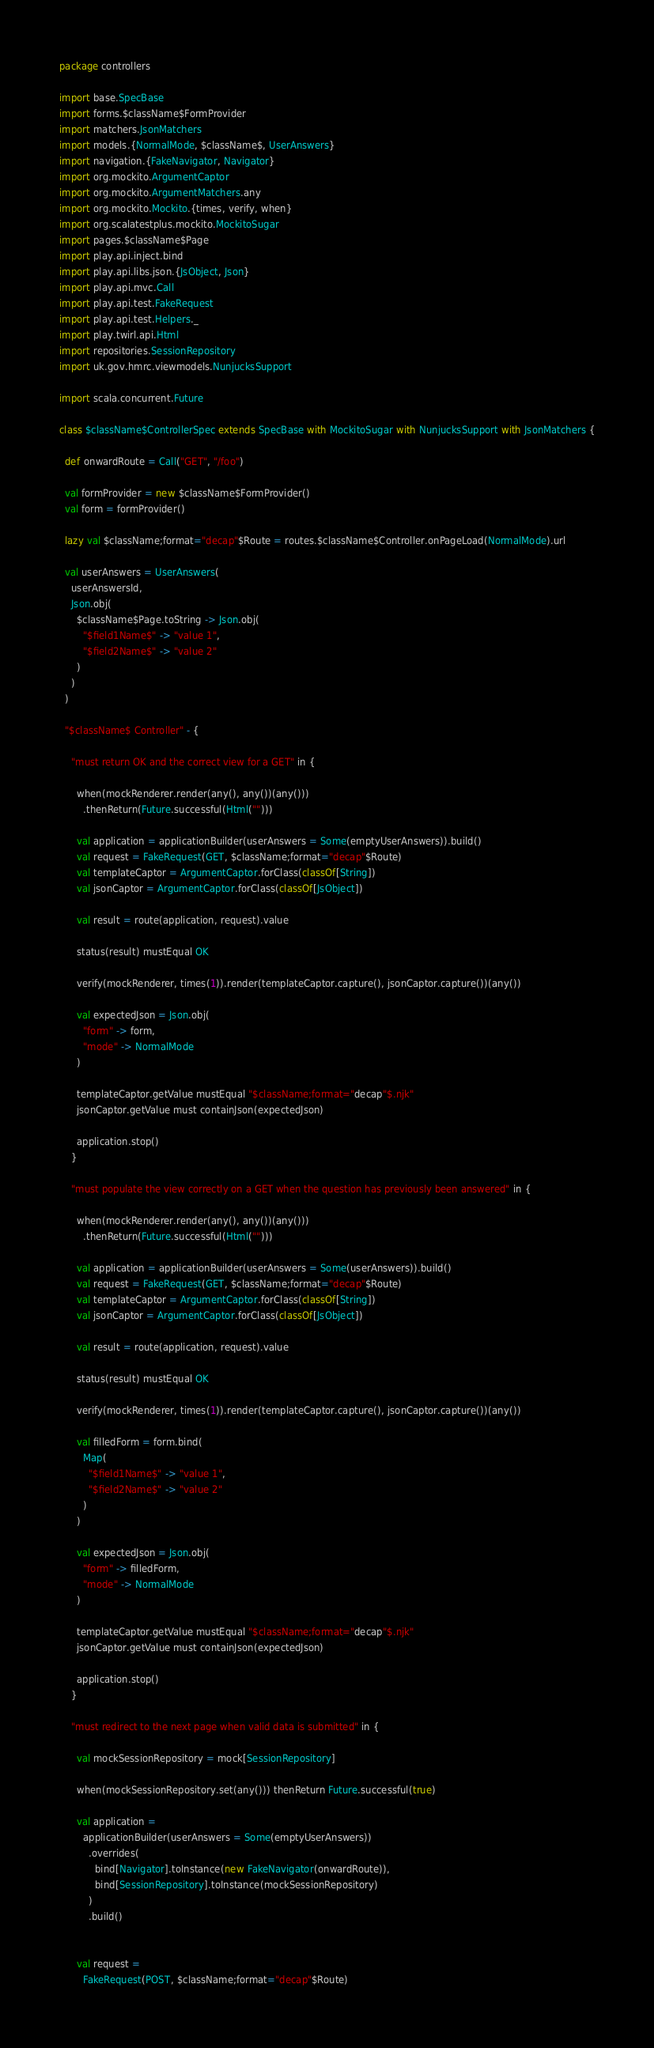<code> <loc_0><loc_0><loc_500><loc_500><_Scala_>package controllers

import base.SpecBase
import forms.$className$FormProvider
import matchers.JsonMatchers
import models.{NormalMode, $className$, UserAnswers}
import navigation.{FakeNavigator, Navigator}
import org.mockito.ArgumentCaptor
import org.mockito.ArgumentMatchers.any
import org.mockito.Mockito.{times, verify, when}
import org.scalatestplus.mockito.MockitoSugar
import pages.$className$Page
import play.api.inject.bind
import play.api.libs.json.{JsObject, Json}
import play.api.mvc.Call
import play.api.test.FakeRequest
import play.api.test.Helpers._
import play.twirl.api.Html
import repositories.SessionRepository
import uk.gov.hmrc.viewmodels.NunjucksSupport

import scala.concurrent.Future

class $className$ControllerSpec extends SpecBase with MockitoSugar with NunjucksSupport with JsonMatchers {

  def onwardRoute = Call("GET", "/foo")

  val formProvider = new $className$FormProvider()
  val form = formProvider()

  lazy val $className;format="decap"$Route = routes.$className$Controller.onPageLoad(NormalMode).url

  val userAnswers = UserAnswers(
    userAnswersId,
    Json.obj(
      $className$Page.toString -> Json.obj(
        "$field1Name$" -> "value 1",
        "$field2Name$" -> "value 2"
      )
    )
  )

  "$className$ Controller" - {

    "must return OK and the correct view for a GET" in {

      when(mockRenderer.render(any(), any())(any()))
        .thenReturn(Future.successful(Html("")))

      val application = applicationBuilder(userAnswers = Some(emptyUserAnswers)).build()
      val request = FakeRequest(GET, $className;format="decap"$Route)
      val templateCaptor = ArgumentCaptor.forClass(classOf[String])
      val jsonCaptor = ArgumentCaptor.forClass(classOf[JsObject])

      val result = route(application, request).value

      status(result) mustEqual OK

      verify(mockRenderer, times(1)).render(templateCaptor.capture(), jsonCaptor.capture())(any())

      val expectedJson = Json.obj(
        "form" -> form,
        "mode" -> NormalMode
      )

      templateCaptor.getValue mustEqual "$className;format="decap"$.njk"
      jsonCaptor.getValue must containJson(expectedJson)

      application.stop()
    }

    "must populate the view correctly on a GET when the question has previously been answered" in {

      when(mockRenderer.render(any(), any())(any()))
        .thenReturn(Future.successful(Html("")))

      val application = applicationBuilder(userAnswers = Some(userAnswers)).build()
      val request = FakeRequest(GET, $className;format="decap"$Route)
      val templateCaptor = ArgumentCaptor.forClass(classOf[String])
      val jsonCaptor = ArgumentCaptor.forClass(classOf[JsObject])

      val result = route(application, request).value

      status(result) mustEqual OK

      verify(mockRenderer, times(1)).render(templateCaptor.capture(), jsonCaptor.capture())(any())

      val filledForm = form.bind(
        Map(
          "$field1Name$" -> "value 1",
          "$field2Name$" -> "value 2"
        )
      )

      val expectedJson = Json.obj(
        "form" -> filledForm,
        "mode" -> NormalMode
      )

      templateCaptor.getValue mustEqual "$className;format="decap"$.njk"
      jsonCaptor.getValue must containJson(expectedJson)

      application.stop()
    }

    "must redirect to the next page when valid data is submitted" in {

      val mockSessionRepository = mock[SessionRepository]

      when(mockSessionRepository.set(any())) thenReturn Future.successful(true)

      val application =
        applicationBuilder(userAnswers = Some(emptyUserAnswers))
          .overrides(
            bind[Navigator].toInstance(new FakeNavigator(onwardRoute)),
            bind[SessionRepository].toInstance(mockSessionRepository)
          )
          .build()


      val request =
        FakeRequest(POST, $className;format="decap"$Route)</code> 